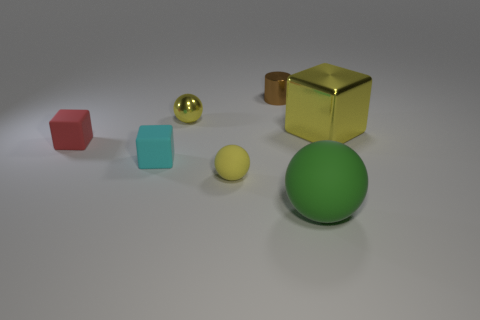Add 2 red blocks. How many objects exist? 9 Subtract all spheres. How many objects are left? 4 Add 2 small rubber spheres. How many small rubber spheres exist? 3 Subtract 0 gray cubes. How many objects are left? 7 Subtract all small yellow balls. Subtract all tiny red objects. How many objects are left? 4 Add 2 yellow rubber objects. How many yellow rubber objects are left? 3 